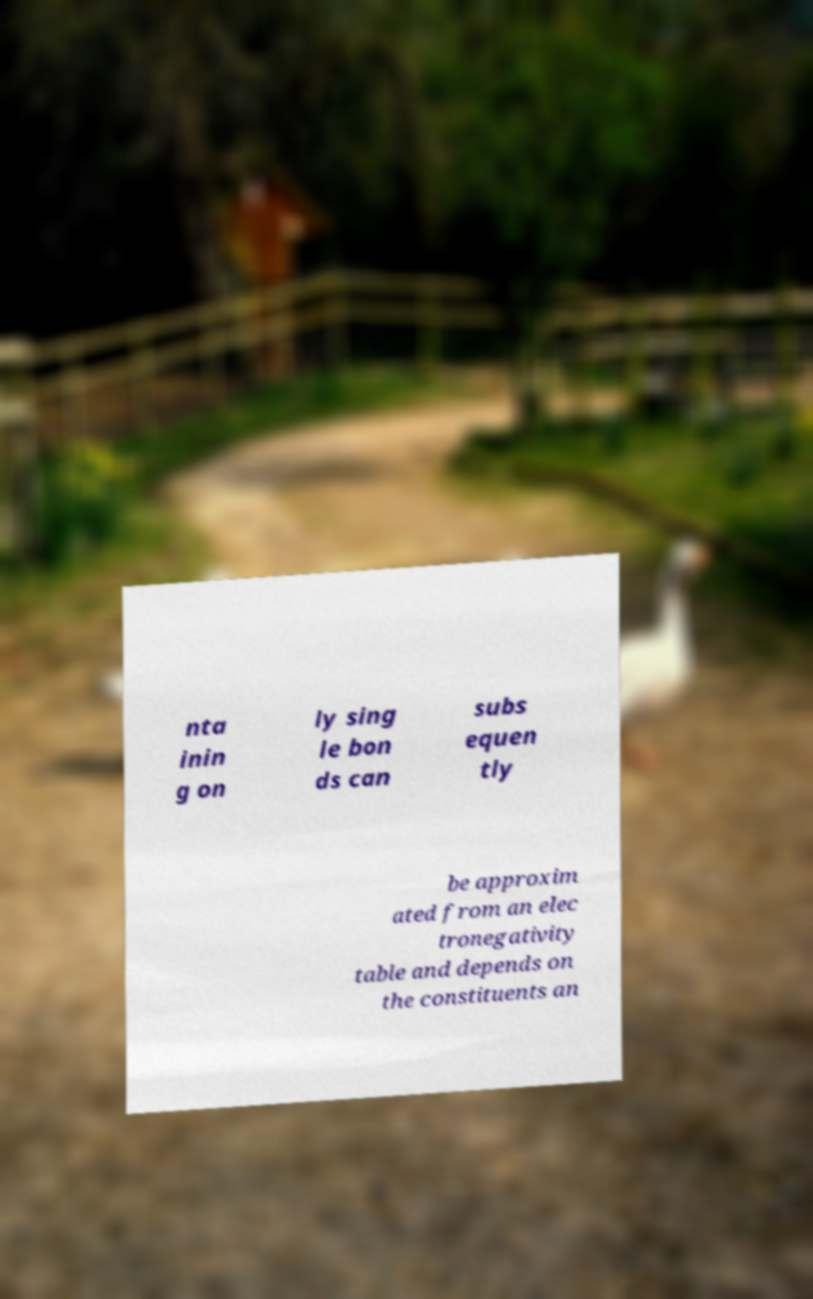Could you assist in decoding the text presented in this image and type it out clearly? nta inin g on ly sing le bon ds can subs equen tly be approxim ated from an elec tronegativity table and depends on the constituents an 